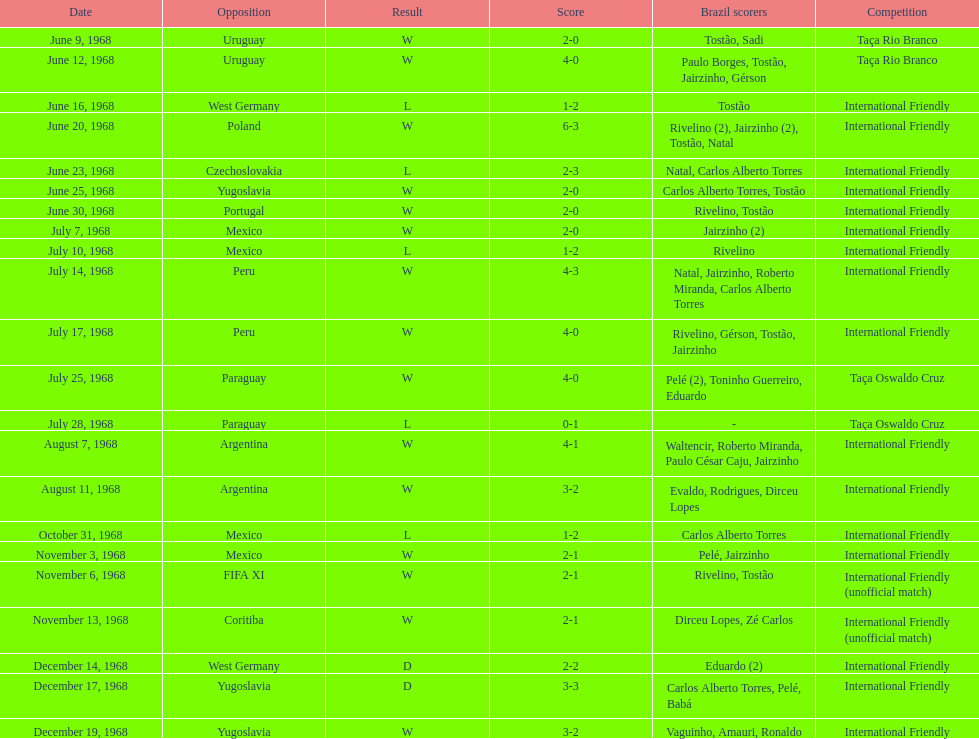Number of losses 5. Can you parse all the data within this table? {'header': ['Date', 'Opposition', 'Result', 'Score', 'Brazil scorers', 'Competition'], 'rows': [['June 9, 1968', 'Uruguay', 'W', '2-0', 'Tostão, Sadi', 'Taça Rio Branco'], ['June 12, 1968', 'Uruguay', 'W', '4-0', 'Paulo Borges, Tostão, Jairzinho, Gérson', 'Taça Rio Branco'], ['June 16, 1968', 'West Germany', 'L', '1-2', 'Tostão', 'International Friendly'], ['June 20, 1968', 'Poland', 'W', '6-3', 'Rivelino (2), Jairzinho (2), Tostão, Natal', 'International Friendly'], ['June 23, 1968', 'Czechoslovakia', 'L', '2-3', 'Natal, Carlos Alberto Torres', 'International Friendly'], ['June 25, 1968', 'Yugoslavia', 'W', '2-0', 'Carlos Alberto Torres, Tostão', 'International Friendly'], ['June 30, 1968', 'Portugal', 'W', '2-0', 'Rivelino, Tostão', 'International Friendly'], ['July 7, 1968', 'Mexico', 'W', '2-0', 'Jairzinho (2)', 'International Friendly'], ['July 10, 1968', 'Mexico', 'L', '1-2', 'Rivelino', 'International Friendly'], ['July 14, 1968', 'Peru', 'W', '4-3', 'Natal, Jairzinho, Roberto Miranda, Carlos Alberto Torres', 'International Friendly'], ['July 17, 1968', 'Peru', 'W', '4-0', 'Rivelino, Gérson, Tostão, Jairzinho', 'International Friendly'], ['July 25, 1968', 'Paraguay', 'W', '4-0', 'Pelé (2), Toninho Guerreiro, Eduardo', 'Taça Oswaldo Cruz'], ['July 28, 1968', 'Paraguay', 'L', '0-1', '-', 'Taça Oswaldo Cruz'], ['August 7, 1968', 'Argentina', 'W', '4-1', 'Waltencir, Roberto Miranda, Paulo César Caju, Jairzinho', 'International Friendly'], ['August 11, 1968', 'Argentina', 'W', '3-2', 'Evaldo, Rodrigues, Dirceu Lopes', 'International Friendly'], ['October 31, 1968', 'Mexico', 'L', '1-2', 'Carlos Alberto Torres', 'International Friendly'], ['November 3, 1968', 'Mexico', 'W', '2-1', 'Pelé, Jairzinho', 'International Friendly'], ['November 6, 1968', 'FIFA XI', 'W', '2-1', 'Rivelino, Tostão', 'International Friendly (unofficial match)'], ['November 13, 1968', 'Coritiba', 'W', '2-1', 'Dirceu Lopes, Zé Carlos', 'International Friendly (unofficial match)'], ['December 14, 1968', 'West Germany', 'D', '2-2', 'Eduardo (2)', 'International Friendly'], ['December 17, 1968', 'Yugoslavia', 'D', '3-3', 'Carlos Alberto Torres, Pelé, Babá', 'International Friendly'], ['December 19, 1968', 'Yugoslavia', 'W', '3-2', 'Vaguinho, Amauri, Ronaldo', 'International Friendly']]} 